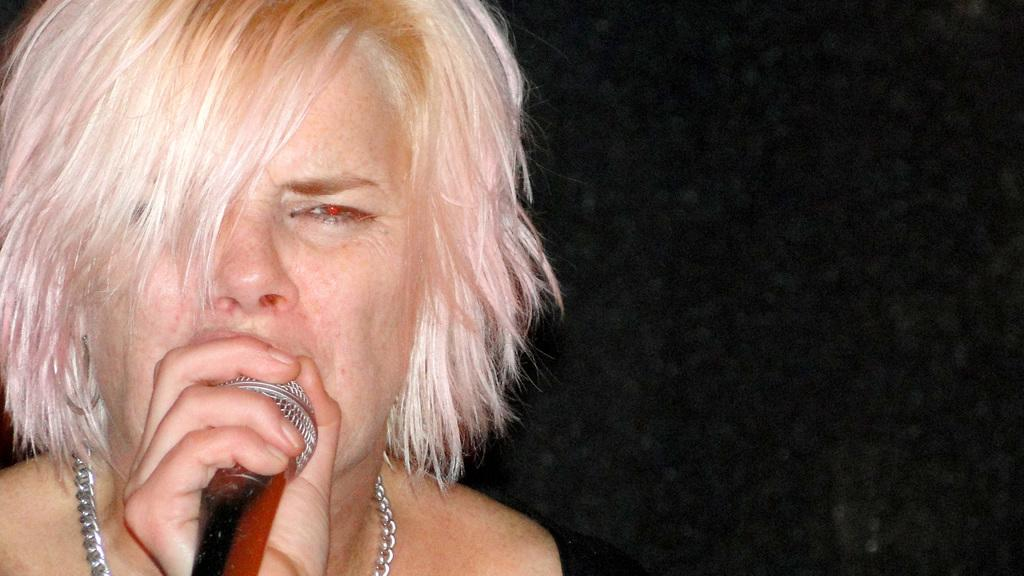Who is the main subject in the image? There is a woman in the image. What is the woman holding in the image? The woman is holding a mic. What type of accessory is the woman wearing? The woman is wearing a metal chain. Can you describe the background of the image? The background of the image is dark. Are there any deer visible in the image? No, there are no deer present in the image. What time of day does the image appear to take place, considering the dark background? The image's background is dark, but there is no specific indication of the time of day. 